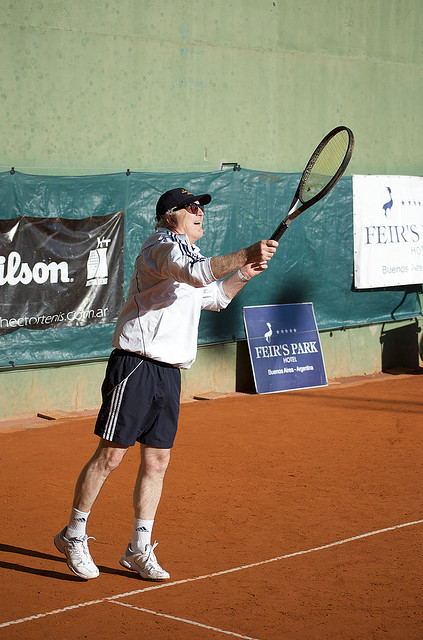Extract all visible text content from this image. ilson FEIR'S FEIR'S PARK 